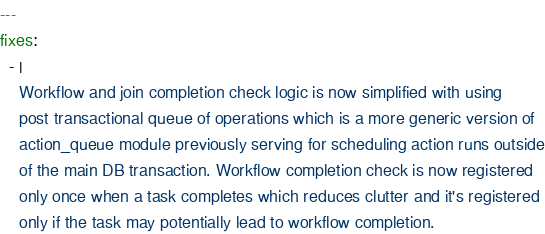<code> <loc_0><loc_0><loc_500><loc_500><_YAML_>---
fixes:
  - |
    Workflow and join completion check logic is now simplified with using
    post transactional queue of operations which is a more generic version of
    action_queue module previously serving for scheduling action runs outside
    of the main DB transaction. Workflow completion check is now registered
    only once when a task completes which reduces clutter and it's registered
    only if the task may potentially lead to workflow completion.

</code> 